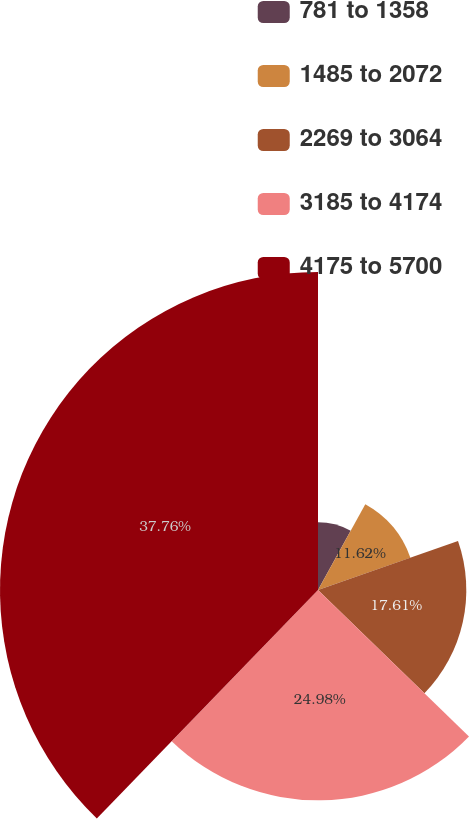Convert chart. <chart><loc_0><loc_0><loc_500><loc_500><pie_chart><fcel>781 to 1358<fcel>1485 to 2072<fcel>2269 to 3064<fcel>3185 to 4174<fcel>4175 to 5700<nl><fcel>8.03%<fcel>11.62%<fcel>17.61%<fcel>24.98%<fcel>37.76%<nl></chart> 